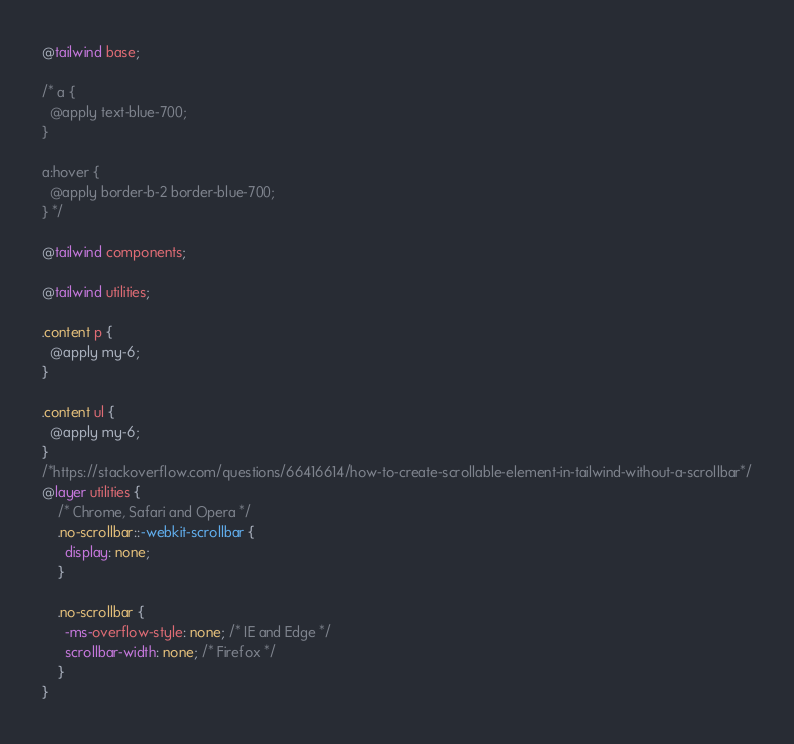Convert code to text. <code><loc_0><loc_0><loc_500><loc_500><_CSS_>@tailwind base;

/* a {
  @apply text-blue-700;
}

a:hover {
  @apply border-b-2 border-blue-700;
} */

@tailwind components;

@tailwind utilities;

.content p {
  @apply my-6;
}

.content ul {
  @apply my-6;
}
/*https://stackoverflow.com/questions/66416614/how-to-create-scrollable-element-in-tailwind-without-a-scrollbar*/
@layer utilities {
    /* Chrome, Safari and Opera */
    .no-scrollbar::-webkit-scrollbar {
      display: none;
    }

    .no-scrollbar {
      -ms-overflow-style: none; /* IE and Edge */
      scrollbar-width: none; /* Firefox */
    }
}
</code> 